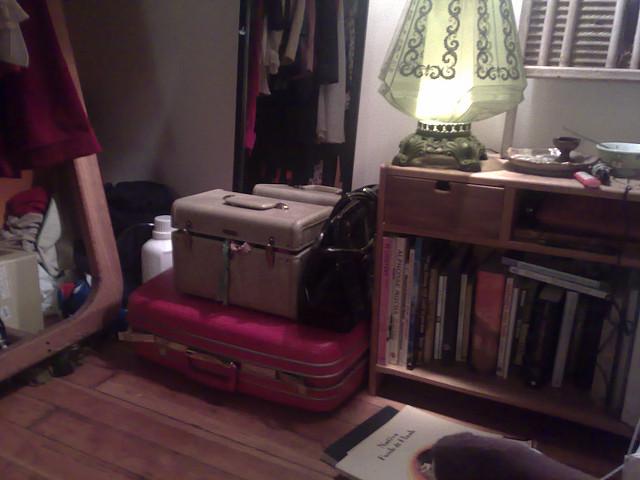Is the lampshade straight?
Quick response, please. Yes. Are they packing a suitcase?
Short answer required. Yes. How many colors are the three pieces of luggage?
Be succinct. 3. Is the lamp off?
Quick response, please. No. What is the medium sized tan case used for?
Keep it brief. Makeup. How many suitcases can be seen?
Concise answer only. 2. What is meant to be put in the bags?
Short answer required. Clothes. 